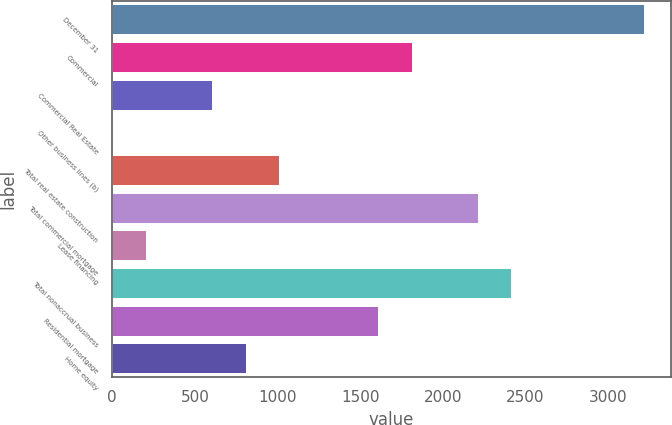Convert chart to OTSL. <chart><loc_0><loc_0><loc_500><loc_500><bar_chart><fcel>December 31<fcel>Commercial<fcel>Commercial Real Estate<fcel>Other business lines (b)<fcel>Total real estate construction<fcel>Total commercial mortgage<fcel>Lease financing<fcel>Total nonaccrual business<fcel>Residential mortgage<fcel>Home equity<nl><fcel>3217.4<fcel>1811.1<fcel>605.7<fcel>3<fcel>1007.5<fcel>2212.9<fcel>203.9<fcel>2413.8<fcel>1610.2<fcel>806.6<nl></chart> 